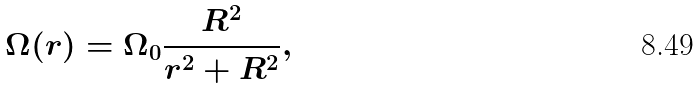<formula> <loc_0><loc_0><loc_500><loc_500>\Omega ( r ) = \Omega _ { 0 } \frac { R ^ { 2 } } { r ^ { 2 } + R ^ { 2 } } ,</formula> 